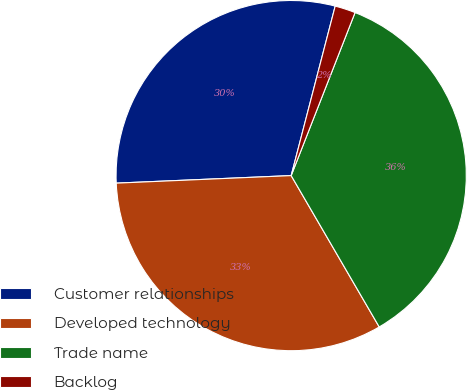Convert chart. <chart><loc_0><loc_0><loc_500><loc_500><pie_chart><fcel>Customer relationships<fcel>Developed technology<fcel>Trade name<fcel>Backlog<nl><fcel>29.73%<fcel>32.7%<fcel>35.67%<fcel>1.9%<nl></chart> 